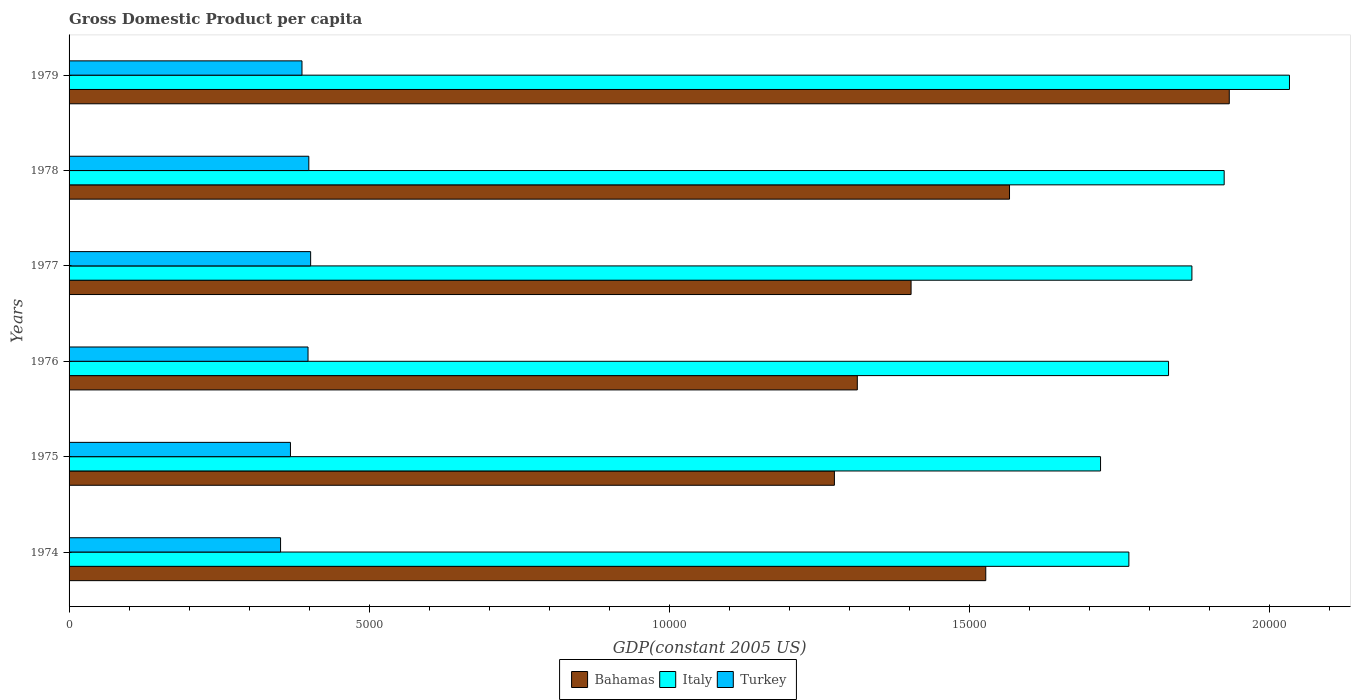How many different coloured bars are there?
Give a very brief answer. 3. How many groups of bars are there?
Your answer should be very brief. 6. Are the number of bars per tick equal to the number of legend labels?
Your answer should be compact. Yes. How many bars are there on the 3rd tick from the bottom?
Make the answer very short. 3. What is the GDP per capita in Bahamas in 1978?
Keep it short and to the point. 1.57e+04. Across all years, what is the maximum GDP per capita in Turkey?
Give a very brief answer. 4025.51. Across all years, what is the minimum GDP per capita in Italy?
Ensure brevity in your answer.  1.72e+04. In which year was the GDP per capita in Bahamas maximum?
Offer a very short reply. 1979. In which year was the GDP per capita in Bahamas minimum?
Your answer should be very brief. 1975. What is the total GDP per capita in Turkey in the graph?
Offer a terse response. 2.31e+04. What is the difference between the GDP per capita in Bahamas in 1974 and that in 1977?
Your answer should be very brief. 1244.49. What is the difference between the GDP per capita in Bahamas in 1978 and the GDP per capita in Turkey in 1976?
Give a very brief answer. 1.17e+04. What is the average GDP per capita in Turkey per year?
Keep it short and to the point. 3849.64. In the year 1979, what is the difference between the GDP per capita in Bahamas and GDP per capita in Italy?
Offer a terse response. -1003.17. What is the ratio of the GDP per capita in Turkey in 1975 to that in 1976?
Offer a terse response. 0.93. Is the GDP per capita in Italy in 1974 less than that in 1975?
Your response must be concise. No. What is the difference between the highest and the second highest GDP per capita in Turkey?
Keep it short and to the point. 30.36. What is the difference between the highest and the lowest GDP per capita in Turkey?
Make the answer very short. 501.14. Is the sum of the GDP per capita in Turkey in 1974 and 1977 greater than the maximum GDP per capita in Bahamas across all years?
Your answer should be very brief. No. What does the 1st bar from the top in 1975 represents?
Offer a terse response. Turkey. What does the 1st bar from the bottom in 1976 represents?
Your answer should be very brief. Bahamas. Are all the bars in the graph horizontal?
Your response must be concise. Yes. Does the graph contain any zero values?
Keep it short and to the point. No. How are the legend labels stacked?
Provide a succinct answer. Horizontal. What is the title of the graph?
Your answer should be very brief. Gross Domestic Product per capita. Does "Lao PDR" appear as one of the legend labels in the graph?
Provide a succinct answer. No. What is the label or title of the X-axis?
Provide a succinct answer. GDP(constant 2005 US). What is the GDP(constant 2005 US) in Bahamas in 1974?
Make the answer very short. 1.53e+04. What is the GDP(constant 2005 US) of Italy in 1974?
Your answer should be very brief. 1.77e+04. What is the GDP(constant 2005 US) of Turkey in 1974?
Your answer should be compact. 3524.37. What is the GDP(constant 2005 US) in Bahamas in 1975?
Offer a very short reply. 1.28e+04. What is the GDP(constant 2005 US) in Italy in 1975?
Provide a succinct answer. 1.72e+04. What is the GDP(constant 2005 US) of Turkey in 1975?
Provide a succinct answer. 3689.21. What is the GDP(constant 2005 US) of Bahamas in 1976?
Ensure brevity in your answer.  1.31e+04. What is the GDP(constant 2005 US) of Italy in 1976?
Ensure brevity in your answer.  1.83e+04. What is the GDP(constant 2005 US) in Turkey in 1976?
Your response must be concise. 3982.15. What is the GDP(constant 2005 US) of Bahamas in 1977?
Your answer should be very brief. 1.40e+04. What is the GDP(constant 2005 US) in Italy in 1977?
Keep it short and to the point. 1.87e+04. What is the GDP(constant 2005 US) in Turkey in 1977?
Offer a terse response. 4025.51. What is the GDP(constant 2005 US) of Bahamas in 1978?
Provide a short and direct response. 1.57e+04. What is the GDP(constant 2005 US) in Italy in 1978?
Make the answer very short. 1.92e+04. What is the GDP(constant 2005 US) in Turkey in 1978?
Offer a very short reply. 3995.15. What is the GDP(constant 2005 US) of Bahamas in 1979?
Your answer should be very brief. 1.93e+04. What is the GDP(constant 2005 US) of Italy in 1979?
Provide a succinct answer. 2.03e+04. What is the GDP(constant 2005 US) of Turkey in 1979?
Your response must be concise. 3881.47. Across all years, what is the maximum GDP(constant 2005 US) in Bahamas?
Offer a terse response. 1.93e+04. Across all years, what is the maximum GDP(constant 2005 US) of Italy?
Provide a short and direct response. 2.03e+04. Across all years, what is the maximum GDP(constant 2005 US) of Turkey?
Give a very brief answer. 4025.51. Across all years, what is the minimum GDP(constant 2005 US) of Bahamas?
Provide a succinct answer. 1.28e+04. Across all years, what is the minimum GDP(constant 2005 US) of Italy?
Provide a short and direct response. 1.72e+04. Across all years, what is the minimum GDP(constant 2005 US) of Turkey?
Give a very brief answer. 3524.37. What is the total GDP(constant 2005 US) in Bahamas in the graph?
Your response must be concise. 9.02e+04. What is the total GDP(constant 2005 US) in Italy in the graph?
Your answer should be very brief. 1.11e+05. What is the total GDP(constant 2005 US) of Turkey in the graph?
Your answer should be compact. 2.31e+04. What is the difference between the GDP(constant 2005 US) of Bahamas in 1974 and that in 1975?
Provide a succinct answer. 2522.12. What is the difference between the GDP(constant 2005 US) in Italy in 1974 and that in 1975?
Offer a very short reply. 472.11. What is the difference between the GDP(constant 2005 US) of Turkey in 1974 and that in 1975?
Make the answer very short. -164.84. What is the difference between the GDP(constant 2005 US) of Bahamas in 1974 and that in 1976?
Make the answer very short. 2140.58. What is the difference between the GDP(constant 2005 US) of Italy in 1974 and that in 1976?
Provide a short and direct response. -661.03. What is the difference between the GDP(constant 2005 US) in Turkey in 1974 and that in 1976?
Make the answer very short. -457.79. What is the difference between the GDP(constant 2005 US) in Bahamas in 1974 and that in 1977?
Provide a short and direct response. 1244.49. What is the difference between the GDP(constant 2005 US) in Italy in 1974 and that in 1977?
Give a very brief answer. -1050.52. What is the difference between the GDP(constant 2005 US) of Turkey in 1974 and that in 1977?
Your response must be concise. -501.14. What is the difference between the GDP(constant 2005 US) in Bahamas in 1974 and that in 1978?
Offer a very short reply. -395.84. What is the difference between the GDP(constant 2005 US) of Italy in 1974 and that in 1978?
Ensure brevity in your answer.  -1588.09. What is the difference between the GDP(constant 2005 US) of Turkey in 1974 and that in 1978?
Offer a very short reply. -470.78. What is the difference between the GDP(constant 2005 US) in Bahamas in 1974 and that in 1979?
Provide a short and direct response. -4058. What is the difference between the GDP(constant 2005 US) of Italy in 1974 and that in 1979?
Provide a succinct answer. -2676.28. What is the difference between the GDP(constant 2005 US) in Turkey in 1974 and that in 1979?
Your answer should be compact. -357.1. What is the difference between the GDP(constant 2005 US) of Bahamas in 1975 and that in 1976?
Your answer should be very brief. -381.54. What is the difference between the GDP(constant 2005 US) in Italy in 1975 and that in 1976?
Make the answer very short. -1133.14. What is the difference between the GDP(constant 2005 US) in Turkey in 1975 and that in 1976?
Your answer should be very brief. -292.94. What is the difference between the GDP(constant 2005 US) of Bahamas in 1975 and that in 1977?
Make the answer very short. -1277.63. What is the difference between the GDP(constant 2005 US) in Italy in 1975 and that in 1977?
Provide a short and direct response. -1522.63. What is the difference between the GDP(constant 2005 US) of Turkey in 1975 and that in 1977?
Your answer should be very brief. -336.3. What is the difference between the GDP(constant 2005 US) in Bahamas in 1975 and that in 1978?
Your answer should be compact. -2917.97. What is the difference between the GDP(constant 2005 US) in Italy in 1975 and that in 1978?
Provide a succinct answer. -2060.2. What is the difference between the GDP(constant 2005 US) of Turkey in 1975 and that in 1978?
Make the answer very short. -305.94. What is the difference between the GDP(constant 2005 US) of Bahamas in 1975 and that in 1979?
Your answer should be very brief. -6580.13. What is the difference between the GDP(constant 2005 US) of Italy in 1975 and that in 1979?
Your answer should be very brief. -3148.38. What is the difference between the GDP(constant 2005 US) in Turkey in 1975 and that in 1979?
Your answer should be compact. -192.26. What is the difference between the GDP(constant 2005 US) in Bahamas in 1976 and that in 1977?
Give a very brief answer. -896.09. What is the difference between the GDP(constant 2005 US) in Italy in 1976 and that in 1977?
Keep it short and to the point. -389.49. What is the difference between the GDP(constant 2005 US) of Turkey in 1976 and that in 1977?
Offer a terse response. -43.35. What is the difference between the GDP(constant 2005 US) in Bahamas in 1976 and that in 1978?
Provide a short and direct response. -2536.43. What is the difference between the GDP(constant 2005 US) in Italy in 1976 and that in 1978?
Offer a very short reply. -927.06. What is the difference between the GDP(constant 2005 US) of Turkey in 1976 and that in 1978?
Provide a succinct answer. -13. What is the difference between the GDP(constant 2005 US) in Bahamas in 1976 and that in 1979?
Your answer should be compact. -6198.59. What is the difference between the GDP(constant 2005 US) of Italy in 1976 and that in 1979?
Your answer should be very brief. -2015.25. What is the difference between the GDP(constant 2005 US) of Turkey in 1976 and that in 1979?
Your response must be concise. 100.69. What is the difference between the GDP(constant 2005 US) of Bahamas in 1977 and that in 1978?
Make the answer very short. -1640.33. What is the difference between the GDP(constant 2005 US) in Italy in 1977 and that in 1978?
Provide a succinct answer. -537.57. What is the difference between the GDP(constant 2005 US) in Turkey in 1977 and that in 1978?
Give a very brief answer. 30.36. What is the difference between the GDP(constant 2005 US) of Bahamas in 1977 and that in 1979?
Your answer should be very brief. -5302.5. What is the difference between the GDP(constant 2005 US) of Italy in 1977 and that in 1979?
Keep it short and to the point. -1625.75. What is the difference between the GDP(constant 2005 US) in Turkey in 1977 and that in 1979?
Offer a very short reply. 144.04. What is the difference between the GDP(constant 2005 US) in Bahamas in 1978 and that in 1979?
Provide a succinct answer. -3662.16. What is the difference between the GDP(constant 2005 US) of Italy in 1978 and that in 1979?
Your answer should be very brief. -1088.19. What is the difference between the GDP(constant 2005 US) of Turkey in 1978 and that in 1979?
Your answer should be very brief. 113.68. What is the difference between the GDP(constant 2005 US) in Bahamas in 1974 and the GDP(constant 2005 US) in Italy in 1975?
Ensure brevity in your answer.  -1912.79. What is the difference between the GDP(constant 2005 US) of Bahamas in 1974 and the GDP(constant 2005 US) of Turkey in 1975?
Provide a succinct answer. 1.16e+04. What is the difference between the GDP(constant 2005 US) of Italy in 1974 and the GDP(constant 2005 US) of Turkey in 1975?
Ensure brevity in your answer.  1.40e+04. What is the difference between the GDP(constant 2005 US) of Bahamas in 1974 and the GDP(constant 2005 US) of Italy in 1976?
Provide a succinct answer. -3045.92. What is the difference between the GDP(constant 2005 US) in Bahamas in 1974 and the GDP(constant 2005 US) in Turkey in 1976?
Offer a very short reply. 1.13e+04. What is the difference between the GDP(constant 2005 US) of Italy in 1974 and the GDP(constant 2005 US) of Turkey in 1976?
Your answer should be compact. 1.37e+04. What is the difference between the GDP(constant 2005 US) of Bahamas in 1974 and the GDP(constant 2005 US) of Italy in 1977?
Keep it short and to the point. -3435.42. What is the difference between the GDP(constant 2005 US) in Bahamas in 1974 and the GDP(constant 2005 US) in Turkey in 1977?
Your response must be concise. 1.13e+04. What is the difference between the GDP(constant 2005 US) of Italy in 1974 and the GDP(constant 2005 US) of Turkey in 1977?
Provide a succinct answer. 1.36e+04. What is the difference between the GDP(constant 2005 US) in Bahamas in 1974 and the GDP(constant 2005 US) in Italy in 1978?
Ensure brevity in your answer.  -3972.98. What is the difference between the GDP(constant 2005 US) of Bahamas in 1974 and the GDP(constant 2005 US) of Turkey in 1978?
Provide a short and direct response. 1.13e+04. What is the difference between the GDP(constant 2005 US) in Italy in 1974 and the GDP(constant 2005 US) in Turkey in 1978?
Ensure brevity in your answer.  1.37e+04. What is the difference between the GDP(constant 2005 US) of Bahamas in 1974 and the GDP(constant 2005 US) of Italy in 1979?
Offer a terse response. -5061.17. What is the difference between the GDP(constant 2005 US) in Bahamas in 1974 and the GDP(constant 2005 US) in Turkey in 1979?
Offer a terse response. 1.14e+04. What is the difference between the GDP(constant 2005 US) of Italy in 1974 and the GDP(constant 2005 US) of Turkey in 1979?
Your response must be concise. 1.38e+04. What is the difference between the GDP(constant 2005 US) of Bahamas in 1975 and the GDP(constant 2005 US) of Italy in 1976?
Offer a terse response. -5568.05. What is the difference between the GDP(constant 2005 US) of Bahamas in 1975 and the GDP(constant 2005 US) of Turkey in 1976?
Provide a short and direct response. 8771.71. What is the difference between the GDP(constant 2005 US) of Italy in 1975 and the GDP(constant 2005 US) of Turkey in 1976?
Provide a short and direct response. 1.32e+04. What is the difference between the GDP(constant 2005 US) in Bahamas in 1975 and the GDP(constant 2005 US) in Italy in 1977?
Give a very brief answer. -5957.54. What is the difference between the GDP(constant 2005 US) of Bahamas in 1975 and the GDP(constant 2005 US) of Turkey in 1977?
Provide a short and direct response. 8728.35. What is the difference between the GDP(constant 2005 US) in Italy in 1975 and the GDP(constant 2005 US) in Turkey in 1977?
Make the answer very short. 1.32e+04. What is the difference between the GDP(constant 2005 US) of Bahamas in 1975 and the GDP(constant 2005 US) of Italy in 1978?
Your response must be concise. -6495.11. What is the difference between the GDP(constant 2005 US) in Bahamas in 1975 and the GDP(constant 2005 US) in Turkey in 1978?
Your answer should be very brief. 8758.71. What is the difference between the GDP(constant 2005 US) of Italy in 1975 and the GDP(constant 2005 US) of Turkey in 1978?
Your answer should be compact. 1.32e+04. What is the difference between the GDP(constant 2005 US) in Bahamas in 1975 and the GDP(constant 2005 US) in Italy in 1979?
Provide a short and direct response. -7583.29. What is the difference between the GDP(constant 2005 US) of Bahamas in 1975 and the GDP(constant 2005 US) of Turkey in 1979?
Offer a very short reply. 8872.39. What is the difference between the GDP(constant 2005 US) of Italy in 1975 and the GDP(constant 2005 US) of Turkey in 1979?
Your answer should be very brief. 1.33e+04. What is the difference between the GDP(constant 2005 US) in Bahamas in 1976 and the GDP(constant 2005 US) in Italy in 1977?
Your answer should be compact. -5576. What is the difference between the GDP(constant 2005 US) in Bahamas in 1976 and the GDP(constant 2005 US) in Turkey in 1977?
Provide a short and direct response. 9109.89. What is the difference between the GDP(constant 2005 US) of Italy in 1976 and the GDP(constant 2005 US) of Turkey in 1977?
Your response must be concise. 1.43e+04. What is the difference between the GDP(constant 2005 US) of Bahamas in 1976 and the GDP(constant 2005 US) of Italy in 1978?
Provide a short and direct response. -6113.57. What is the difference between the GDP(constant 2005 US) of Bahamas in 1976 and the GDP(constant 2005 US) of Turkey in 1978?
Ensure brevity in your answer.  9140.25. What is the difference between the GDP(constant 2005 US) of Italy in 1976 and the GDP(constant 2005 US) of Turkey in 1978?
Give a very brief answer. 1.43e+04. What is the difference between the GDP(constant 2005 US) of Bahamas in 1976 and the GDP(constant 2005 US) of Italy in 1979?
Offer a very short reply. -7201.75. What is the difference between the GDP(constant 2005 US) of Bahamas in 1976 and the GDP(constant 2005 US) of Turkey in 1979?
Your answer should be compact. 9253.93. What is the difference between the GDP(constant 2005 US) in Italy in 1976 and the GDP(constant 2005 US) in Turkey in 1979?
Ensure brevity in your answer.  1.44e+04. What is the difference between the GDP(constant 2005 US) in Bahamas in 1977 and the GDP(constant 2005 US) in Italy in 1978?
Offer a terse response. -5217.47. What is the difference between the GDP(constant 2005 US) in Bahamas in 1977 and the GDP(constant 2005 US) in Turkey in 1978?
Give a very brief answer. 1.00e+04. What is the difference between the GDP(constant 2005 US) of Italy in 1977 and the GDP(constant 2005 US) of Turkey in 1978?
Keep it short and to the point. 1.47e+04. What is the difference between the GDP(constant 2005 US) of Bahamas in 1977 and the GDP(constant 2005 US) of Italy in 1979?
Your answer should be compact. -6305.66. What is the difference between the GDP(constant 2005 US) in Bahamas in 1977 and the GDP(constant 2005 US) in Turkey in 1979?
Your answer should be compact. 1.02e+04. What is the difference between the GDP(constant 2005 US) of Italy in 1977 and the GDP(constant 2005 US) of Turkey in 1979?
Offer a terse response. 1.48e+04. What is the difference between the GDP(constant 2005 US) of Bahamas in 1978 and the GDP(constant 2005 US) of Italy in 1979?
Offer a terse response. -4665.33. What is the difference between the GDP(constant 2005 US) of Bahamas in 1978 and the GDP(constant 2005 US) of Turkey in 1979?
Ensure brevity in your answer.  1.18e+04. What is the difference between the GDP(constant 2005 US) in Italy in 1978 and the GDP(constant 2005 US) in Turkey in 1979?
Offer a terse response. 1.54e+04. What is the average GDP(constant 2005 US) of Bahamas per year?
Provide a short and direct response. 1.50e+04. What is the average GDP(constant 2005 US) in Italy per year?
Ensure brevity in your answer.  1.86e+04. What is the average GDP(constant 2005 US) of Turkey per year?
Your answer should be very brief. 3849.64. In the year 1974, what is the difference between the GDP(constant 2005 US) of Bahamas and GDP(constant 2005 US) of Italy?
Your answer should be very brief. -2384.89. In the year 1974, what is the difference between the GDP(constant 2005 US) of Bahamas and GDP(constant 2005 US) of Turkey?
Your response must be concise. 1.18e+04. In the year 1974, what is the difference between the GDP(constant 2005 US) in Italy and GDP(constant 2005 US) in Turkey?
Give a very brief answer. 1.41e+04. In the year 1975, what is the difference between the GDP(constant 2005 US) of Bahamas and GDP(constant 2005 US) of Italy?
Offer a very short reply. -4434.91. In the year 1975, what is the difference between the GDP(constant 2005 US) in Bahamas and GDP(constant 2005 US) in Turkey?
Your answer should be very brief. 9064.65. In the year 1975, what is the difference between the GDP(constant 2005 US) in Italy and GDP(constant 2005 US) in Turkey?
Give a very brief answer. 1.35e+04. In the year 1976, what is the difference between the GDP(constant 2005 US) in Bahamas and GDP(constant 2005 US) in Italy?
Your response must be concise. -5186.51. In the year 1976, what is the difference between the GDP(constant 2005 US) in Bahamas and GDP(constant 2005 US) in Turkey?
Provide a short and direct response. 9153.25. In the year 1976, what is the difference between the GDP(constant 2005 US) in Italy and GDP(constant 2005 US) in Turkey?
Your response must be concise. 1.43e+04. In the year 1977, what is the difference between the GDP(constant 2005 US) of Bahamas and GDP(constant 2005 US) of Italy?
Ensure brevity in your answer.  -4679.91. In the year 1977, what is the difference between the GDP(constant 2005 US) of Bahamas and GDP(constant 2005 US) of Turkey?
Keep it short and to the point. 1.00e+04. In the year 1977, what is the difference between the GDP(constant 2005 US) in Italy and GDP(constant 2005 US) in Turkey?
Ensure brevity in your answer.  1.47e+04. In the year 1978, what is the difference between the GDP(constant 2005 US) of Bahamas and GDP(constant 2005 US) of Italy?
Provide a succinct answer. -3577.14. In the year 1978, what is the difference between the GDP(constant 2005 US) of Bahamas and GDP(constant 2005 US) of Turkey?
Provide a succinct answer. 1.17e+04. In the year 1978, what is the difference between the GDP(constant 2005 US) in Italy and GDP(constant 2005 US) in Turkey?
Offer a very short reply. 1.53e+04. In the year 1979, what is the difference between the GDP(constant 2005 US) in Bahamas and GDP(constant 2005 US) in Italy?
Make the answer very short. -1003.17. In the year 1979, what is the difference between the GDP(constant 2005 US) of Bahamas and GDP(constant 2005 US) of Turkey?
Offer a very short reply. 1.55e+04. In the year 1979, what is the difference between the GDP(constant 2005 US) of Italy and GDP(constant 2005 US) of Turkey?
Offer a terse response. 1.65e+04. What is the ratio of the GDP(constant 2005 US) of Bahamas in 1974 to that in 1975?
Your response must be concise. 1.2. What is the ratio of the GDP(constant 2005 US) of Italy in 1974 to that in 1975?
Your response must be concise. 1.03. What is the ratio of the GDP(constant 2005 US) of Turkey in 1974 to that in 1975?
Offer a terse response. 0.96. What is the ratio of the GDP(constant 2005 US) in Bahamas in 1974 to that in 1976?
Your answer should be very brief. 1.16. What is the ratio of the GDP(constant 2005 US) of Italy in 1974 to that in 1976?
Offer a terse response. 0.96. What is the ratio of the GDP(constant 2005 US) in Turkey in 1974 to that in 1976?
Your answer should be compact. 0.89. What is the ratio of the GDP(constant 2005 US) of Bahamas in 1974 to that in 1977?
Provide a succinct answer. 1.09. What is the ratio of the GDP(constant 2005 US) of Italy in 1974 to that in 1977?
Keep it short and to the point. 0.94. What is the ratio of the GDP(constant 2005 US) in Turkey in 1974 to that in 1977?
Your answer should be compact. 0.88. What is the ratio of the GDP(constant 2005 US) of Bahamas in 1974 to that in 1978?
Keep it short and to the point. 0.97. What is the ratio of the GDP(constant 2005 US) of Italy in 1974 to that in 1978?
Make the answer very short. 0.92. What is the ratio of the GDP(constant 2005 US) in Turkey in 1974 to that in 1978?
Keep it short and to the point. 0.88. What is the ratio of the GDP(constant 2005 US) in Bahamas in 1974 to that in 1979?
Offer a very short reply. 0.79. What is the ratio of the GDP(constant 2005 US) in Italy in 1974 to that in 1979?
Your answer should be compact. 0.87. What is the ratio of the GDP(constant 2005 US) of Turkey in 1974 to that in 1979?
Your answer should be very brief. 0.91. What is the ratio of the GDP(constant 2005 US) of Bahamas in 1975 to that in 1976?
Keep it short and to the point. 0.97. What is the ratio of the GDP(constant 2005 US) of Italy in 1975 to that in 1976?
Your answer should be compact. 0.94. What is the ratio of the GDP(constant 2005 US) in Turkey in 1975 to that in 1976?
Provide a succinct answer. 0.93. What is the ratio of the GDP(constant 2005 US) of Bahamas in 1975 to that in 1977?
Offer a very short reply. 0.91. What is the ratio of the GDP(constant 2005 US) in Italy in 1975 to that in 1977?
Offer a very short reply. 0.92. What is the ratio of the GDP(constant 2005 US) in Turkey in 1975 to that in 1977?
Your answer should be compact. 0.92. What is the ratio of the GDP(constant 2005 US) of Bahamas in 1975 to that in 1978?
Your answer should be compact. 0.81. What is the ratio of the GDP(constant 2005 US) in Italy in 1975 to that in 1978?
Offer a terse response. 0.89. What is the ratio of the GDP(constant 2005 US) in Turkey in 1975 to that in 1978?
Offer a very short reply. 0.92. What is the ratio of the GDP(constant 2005 US) in Bahamas in 1975 to that in 1979?
Your response must be concise. 0.66. What is the ratio of the GDP(constant 2005 US) in Italy in 1975 to that in 1979?
Ensure brevity in your answer.  0.85. What is the ratio of the GDP(constant 2005 US) of Turkey in 1975 to that in 1979?
Provide a short and direct response. 0.95. What is the ratio of the GDP(constant 2005 US) of Bahamas in 1976 to that in 1977?
Keep it short and to the point. 0.94. What is the ratio of the GDP(constant 2005 US) in Italy in 1976 to that in 1977?
Offer a terse response. 0.98. What is the ratio of the GDP(constant 2005 US) of Bahamas in 1976 to that in 1978?
Offer a terse response. 0.84. What is the ratio of the GDP(constant 2005 US) in Italy in 1976 to that in 1978?
Your answer should be compact. 0.95. What is the ratio of the GDP(constant 2005 US) of Turkey in 1976 to that in 1978?
Ensure brevity in your answer.  1. What is the ratio of the GDP(constant 2005 US) of Bahamas in 1976 to that in 1979?
Provide a succinct answer. 0.68. What is the ratio of the GDP(constant 2005 US) in Italy in 1976 to that in 1979?
Provide a succinct answer. 0.9. What is the ratio of the GDP(constant 2005 US) in Turkey in 1976 to that in 1979?
Provide a succinct answer. 1.03. What is the ratio of the GDP(constant 2005 US) in Bahamas in 1977 to that in 1978?
Offer a terse response. 0.9. What is the ratio of the GDP(constant 2005 US) in Italy in 1977 to that in 1978?
Provide a short and direct response. 0.97. What is the ratio of the GDP(constant 2005 US) of Turkey in 1977 to that in 1978?
Give a very brief answer. 1.01. What is the ratio of the GDP(constant 2005 US) of Bahamas in 1977 to that in 1979?
Your answer should be very brief. 0.73. What is the ratio of the GDP(constant 2005 US) of Italy in 1977 to that in 1979?
Make the answer very short. 0.92. What is the ratio of the GDP(constant 2005 US) in Turkey in 1977 to that in 1979?
Offer a very short reply. 1.04. What is the ratio of the GDP(constant 2005 US) of Bahamas in 1978 to that in 1979?
Provide a short and direct response. 0.81. What is the ratio of the GDP(constant 2005 US) of Italy in 1978 to that in 1979?
Keep it short and to the point. 0.95. What is the ratio of the GDP(constant 2005 US) in Turkey in 1978 to that in 1979?
Make the answer very short. 1.03. What is the difference between the highest and the second highest GDP(constant 2005 US) of Bahamas?
Ensure brevity in your answer.  3662.16. What is the difference between the highest and the second highest GDP(constant 2005 US) of Italy?
Your response must be concise. 1088.19. What is the difference between the highest and the second highest GDP(constant 2005 US) of Turkey?
Keep it short and to the point. 30.36. What is the difference between the highest and the lowest GDP(constant 2005 US) in Bahamas?
Your response must be concise. 6580.13. What is the difference between the highest and the lowest GDP(constant 2005 US) in Italy?
Give a very brief answer. 3148.38. What is the difference between the highest and the lowest GDP(constant 2005 US) in Turkey?
Your response must be concise. 501.14. 